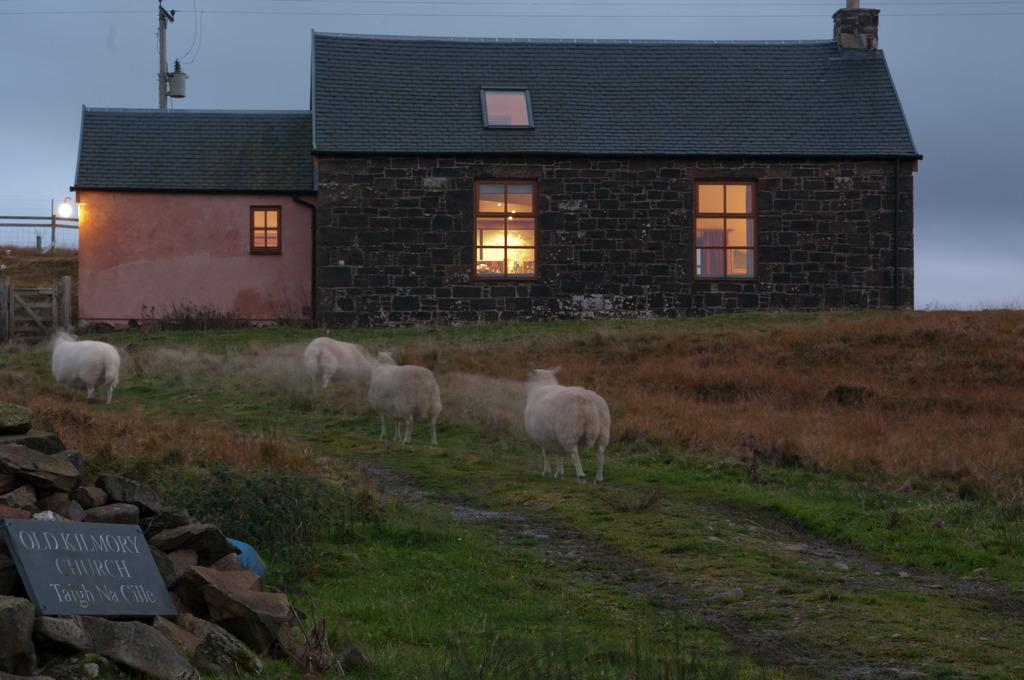What type of vegetation can be seen in the image? There is grass in the image. What animals are present in the image? There are white-colored sheep in the image. What type of structures can be seen in the image? There are houses in the image, and they have windows. Can you describe the lighting in the image? There is light visible in the image. What else is present in the image besides the grass, sheep, and houses? There is a poster and a current pole in the image. What is visible at the top of the image? The sky is visible at the top of the image. What type of education is being offered to the sheep in the image? There is no indication of education being offered to the sheep in the image. How many apples are being held by the houses in the image? There are no apples present in the image, and houses do not hold objects. 